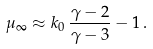<formula> <loc_0><loc_0><loc_500><loc_500>\mu _ { \infty } \approx k _ { 0 } \, \frac { \gamma - 2 } { \gamma - 3 } - 1 \, .</formula> 